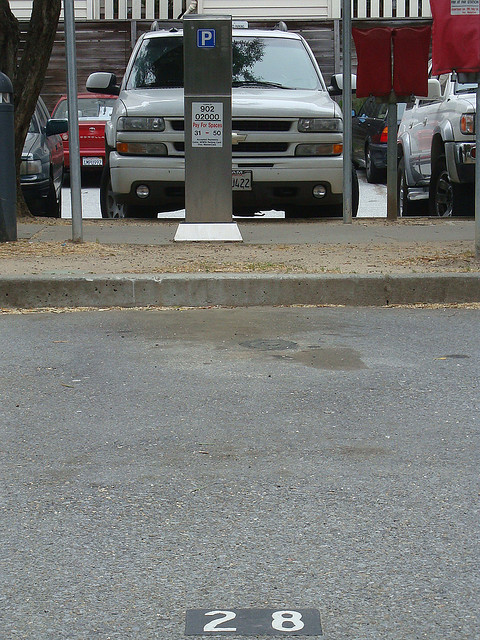<image>What is in the image that can be used to pack items? It is ambiguous. There might be a truck or car in the image that can be used to pack items. What is in the image that can be used to pack items? I am not sure what is in the image that can be used to pack items. It can be seen truck, car or suv. 